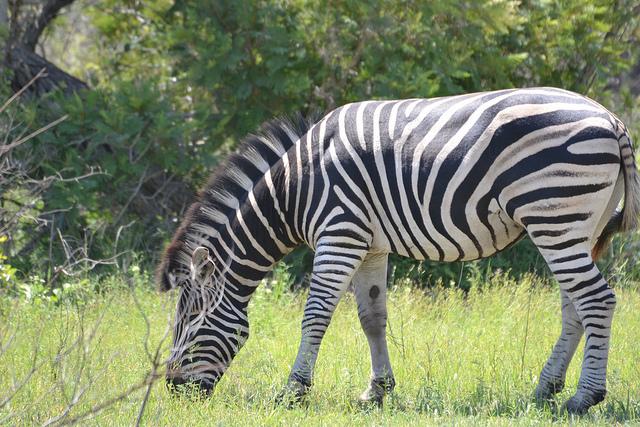What is the zebra doing?
Answer briefly. Eating. Is that a horse?
Short answer required. No. What is this animal?
Write a very short answer. Zebra. Is it a sunny day?
Keep it brief. Yes. 